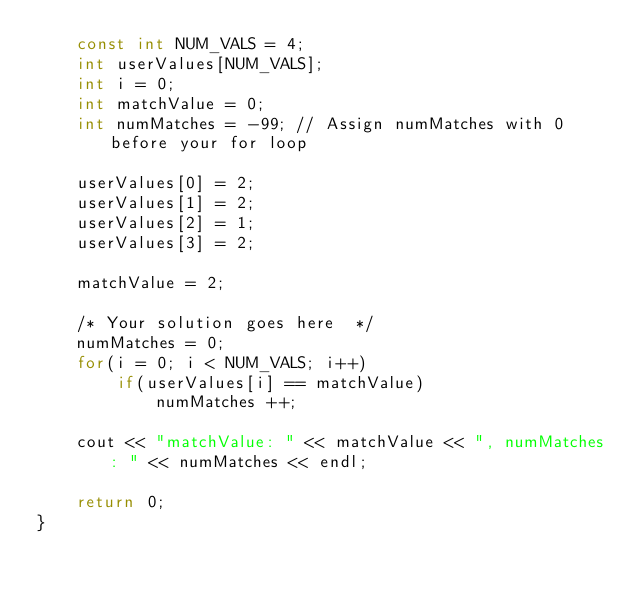<code> <loc_0><loc_0><loc_500><loc_500><_C++_>    const int NUM_VALS = 4;
    int userValues[NUM_VALS];
    int i = 0;
    int matchValue = 0;
    int numMatches = -99; // Assign numMatches with 0 before your for loop
    
    userValues[0] = 2;
    userValues[1] = 2;
    userValues[2] = 1;
    userValues[3] = 2;
    
    matchValue = 2;
    
    /* Your solution goes here  */
    numMatches = 0;
    for(i = 0; i < NUM_VALS; i++)
        if(userValues[i] == matchValue)
            numMatches ++;
    
    cout << "matchValue: " << matchValue << ", numMatches: " << numMatches << endl;
    
    return 0;
}
</code> 